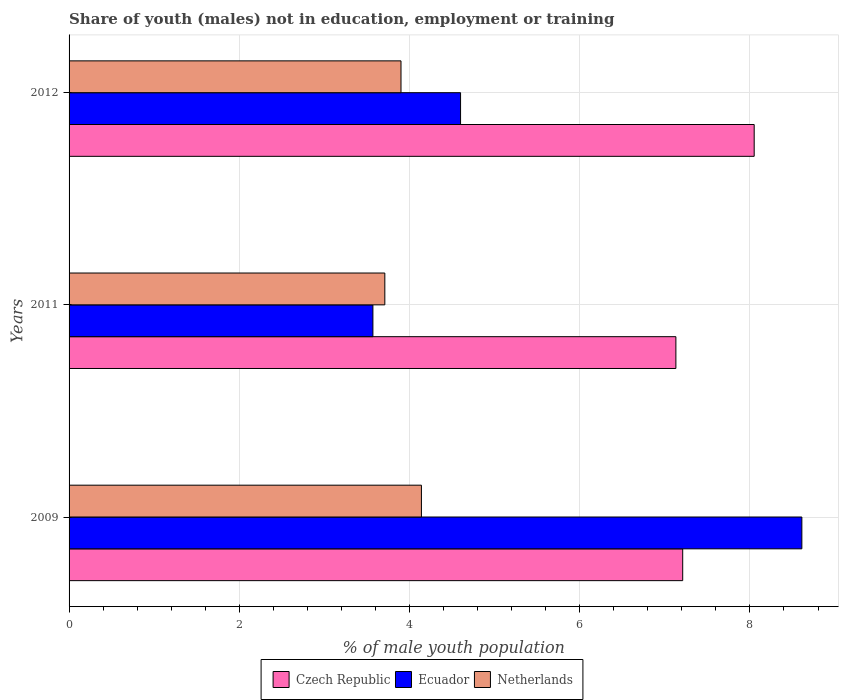Are the number of bars on each tick of the Y-axis equal?
Your answer should be compact. Yes. What is the percentage of unemployed males population in in Ecuador in 2009?
Your answer should be very brief. 8.61. Across all years, what is the maximum percentage of unemployed males population in in Czech Republic?
Provide a succinct answer. 8.05. Across all years, what is the minimum percentage of unemployed males population in in Czech Republic?
Your answer should be very brief. 7.13. In which year was the percentage of unemployed males population in in Czech Republic maximum?
Your answer should be compact. 2012. In which year was the percentage of unemployed males population in in Czech Republic minimum?
Make the answer very short. 2011. What is the total percentage of unemployed males population in in Czech Republic in the graph?
Offer a very short reply. 22.39. What is the difference between the percentage of unemployed males population in in Ecuador in 2009 and that in 2011?
Offer a very short reply. 5.04. What is the difference between the percentage of unemployed males population in in Ecuador in 2009 and the percentage of unemployed males population in in Netherlands in 2012?
Keep it short and to the point. 4.71. What is the average percentage of unemployed males population in in Czech Republic per year?
Provide a short and direct response. 7.46. In the year 2012, what is the difference between the percentage of unemployed males population in in Netherlands and percentage of unemployed males population in in Czech Republic?
Offer a very short reply. -4.15. What is the ratio of the percentage of unemployed males population in in Netherlands in 2011 to that in 2012?
Your answer should be compact. 0.95. What is the difference between the highest and the second highest percentage of unemployed males population in in Ecuador?
Ensure brevity in your answer.  4.01. What is the difference between the highest and the lowest percentage of unemployed males population in in Czech Republic?
Provide a succinct answer. 0.92. What does the 3rd bar from the top in 2009 represents?
Give a very brief answer. Czech Republic. What does the 2nd bar from the bottom in 2011 represents?
Your answer should be compact. Ecuador. Is it the case that in every year, the sum of the percentage of unemployed males population in in Netherlands and percentage of unemployed males population in in Ecuador is greater than the percentage of unemployed males population in in Czech Republic?
Your answer should be very brief. Yes. How many years are there in the graph?
Your answer should be very brief. 3. Are the values on the major ticks of X-axis written in scientific E-notation?
Make the answer very short. No. Does the graph contain grids?
Offer a very short reply. Yes. What is the title of the graph?
Provide a short and direct response. Share of youth (males) not in education, employment or training. Does "Guam" appear as one of the legend labels in the graph?
Keep it short and to the point. No. What is the label or title of the X-axis?
Provide a short and direct response. % of male youth population. What is the % of male youth population of Czech Republic in 2009?
Your answer should be very brief. 7.21. What is the % of male youth population of Ecuador in 2009?
Your response must be concise. 8.61. What is the % of male youth population of Netherlands in 2009?
Provide a short and direct response. 4.14. What is the % of male youth population of Czech Republic in 2011?
Offer a very short reply. 7.13. What is the % of male youth population in Ecuador in 2011?
Your answer should be compact. 3.57. What is the % of male youth population of Netherlands in 2011?
Offer a very short reply. 3.71. What is the % of male youth population of Czech Republic in 2012?
Make the answer very short. 8.05. What is the % of male youth population of Ecuador in 2012?
Provide a short and direct response. 4.6. What is the % of male youth population in Netherlands in 2012?
Your response must be concise. 3.9. Across all years, what is the maximum % of male youth population in Czech Republic?
Give a very brief answer. 8.05. Across all years, what is the maximum % of male youth population of Ecuador?
Provide a short and direct response. 8.61. Across all years, what is the maximum % of male youth population of Netherlands?
Your answer should be compact. 4.14. Across all years, what is the minimum % of male youth population in Czech Republic?
Your answer should be very brief. 7.13. Across all years, what is the minimum % of male youth population in Ecuador?
Keep it short and to the point. 3.57. Across all years, what is the minimum % of male youth population of Netherlands?
Offer a very short reply. 3.71. What is the total % of male youth population in Czech Republic in the graph?
Your answer should be very brief. 22.39. What is the total % of male youth population of Ecuador in the graph?
Your answer should be compact. 16.78. What is the total % of male youth population of Netherlands in the graph?
Ensure brevity in your answer.  11.75. What is the difference between the % of male youth population in Czech Republic in 2009 and that in 2011?
Provide a succinct answer. 0.08. What is the difference between the % of male youth population in Ecuador in 2009 and that in 2011?
Offer a terse response. 5.04. What is the difference between the % of male youth population in Netherlands in 2009 and that in 2011?
Offer a terse response. 0.43. What is the difference between the % of male youth population of Czech Republic in 2009 and that in 2012?
Offer a terse response. -0.84. What is the difference between the % of male youth population in Ecuador in 2009 and that in 2012?
Ensure brevity in your answer.  4.01. What is the difference between the % of male youth population in Netherlands in 2009 and that in 2012?
Your answer should be very brief. 0.24. What is the difference between the % of male youth population in Czech Republic in 2011 and that in 2012?
Your answer should be compact. -0.92. What is the difference between the % of male youth population in Ecuador in 2011 and that in 2012?
Provide a short and direct response. -1.03. What is the difference between the % of male youth population in Netherlands in 2011 and that in 2012?
Offer a terse response. -0.19. What is the difference between the % of male youth population of Czech Republic in 2009 and the % of male youth population of Ecuador in 2011?
Your answer should be compact. 3.64. What is the difference between the % of male youth population in Czech Republic in 2009 and the % of male youth population in Ecuador in 2012?
Your answer should be very brief. 2.61. What is the difference between the % of male youth population of Czech Republic in 2009 and the % of male youth population of Netherlands in 2012?
Offer a very short reply. 3.31. What is the difference between the % of male youth population in Ecuador in 2009 and the % of male youth population in Netherlands in 2012?
Keep it short and to the point. 4.71. What is the difference between the % of male youth population in Czech Republic in 2011 and the % of male youth population in Ecuador in 2012?
Give a very brief answer. 2.53. What is the difference between the % of male youth population in Czech Republic in 2011 and the % of male youth population in Netherlands in 2012?
Offer a terse response. 3.23. What is the difference between the % of male youth population of Ecuador in 2011 and the % of male youth population of Netherlands in 2012?
Offer a very short reply. -0.33. What is the average % of male youth population in Czech Republic per year?
Make the answer very short. 7.46. What is the average % of male youth population of Ecuador per year?
Provide a succinct answer. 5.59. What is the average % of male youth population in Netherlands per year?
Provide a short and direct response. 3.92. In the year 2009, what is the difference between the % of male youth population in Czech Republic and % of male youth population in Ecuador?
Your answer should be very brief. -1.4. In the year 2009, what is the difference between the % of male youth population in Czech Republic and % of male youth population in Netherlands?
Provide a succinct answer. 3.07. In the year 2009, what is the difference between the % of male youth population in Ecuador and % of male youth population in Netherlands?
Make the answer very short. 4.47. In the year 2011, what is the difference between the % of male youth population of Czech Republic and % of male youth population of Ecuador?
Your answer should be very brief. 3.56. In the year 2011, what is the difference between the % of male youth population of Czech Republic and % of male youth population of Netherlands?
Your response must be concise. 3.42. In the year 2011, what is the difference between the % of male youth population in Ecuador and % of male youth population in Netherlands?
Offer a terse response. -0.14. In the year 2012, what is the difference between the % of male youth population in Czech Republic and % of male youth population in Ecuador?
Keep it short and to the point. 3.45. In the year 2012, what is the difference between the % of male youth population of Czech Republic and % of male youth population of Netherlands?
Provide a short and direct response. 4.15. In the year 2012, what is the difference between the % of male youth population in Ecuador and % of male youth population in Netherlands?
Make the answer very short. 0.7. What is the ratio of the % of male youth population of Czech Republic in 2009 to that in 2011?
Offer a very short reply. 1.01. What is the ratio of the % of male youth population in Ecuador in 2009 to that in 2011?
Your answer should be very brief. 2.41. What is the ratio of the % of male youth population in Netherlands in 2009 to that in 2011?
Your answer should be compact. 1.12. What is the ratio of the % of male youth population of Czech Republic in 2009 to that in 2012?
Your answer should be compact. 0.9. What is the ratio of the % of male youth population of Ecuador in 2009 to that in 2012?
Your answer should be very brief. 1.87. What is the ratio of the % of male youth population of Netherlands in 2009 to that in 2012?
Give a very brief answer. 1.06. What is the ratio of the % of male youth population in Czech Republic in 2011 to that in 2012?
Keep it short and to the point. 0.89. What is the ratio of the % of male youth population in Ecuador in 2011 to that in 2012?
Provide a short and direct response. 0.78. What is the ratio of the % of male youth population in Netherlands in 2011 to that in 2012?
Offer a very short reply. 0.95. What is the difference between the highest and the second highest % of male youth population of Czech Republic?
Offer a very short reply. 0.84. What is the difference between the highest and the second highest % of male youth population in Ecuador?
Keep it short and to the point. 4.01. What is the difference between the highest and the second highest % of male youth population of Netherlands?
Offer a very short reply. 0.24. What is the difference between the highest and the lowest % of male youth population of Ecuador?
Offer a terse response. 5.04. What is the difference between the highest and the lowest % of male youth population in Netherlands?
Ensure brevity in your answer.  0.43. 